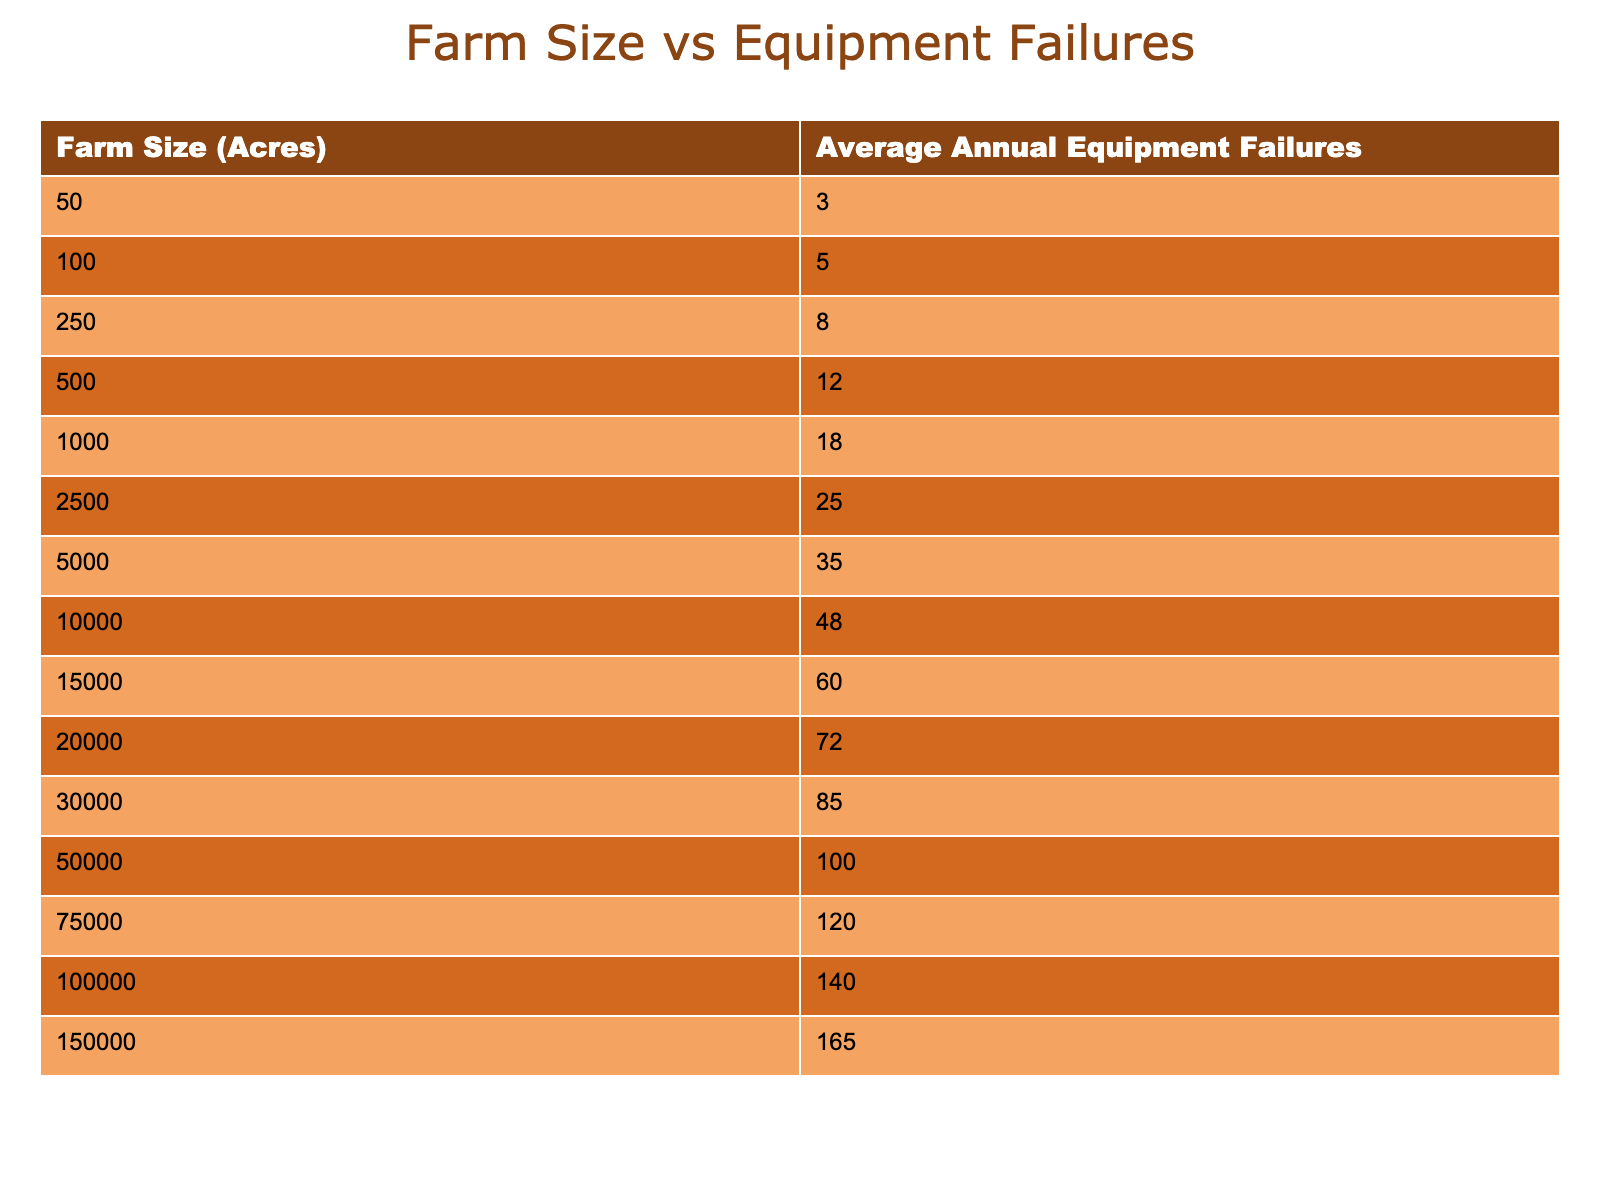What is the average number of equipment failures for farms larger than 10,000 acres? To find the average, we sum the number of failures for farms greater than 10,000 acres: 48 (10,000) + 60 (15,000) + 72 (20,000) + 85 (30,000) + 100 (50,000) + 120 (75,000) + 140 (100,000) + 165 (150,000) =  810. There are 8 entries, so the average is 810 / 8 = 101.25.
Answer: 101.25 How many total equipment failures occur for farms between 1,000 and 20,000 acres inclusive? The total for farms from 1,000 to 20,000 acres is the sum of failures at 1,000 (18) + 2,500 (25) + 5,000 (35) + 10,000 (48) + 15,000 (60) + 20,000 (72) = 258.
Answer: 258 Is there a farm size that sustains exactly 100 equipment failures? Upon examining the table, a farm size of 50,000 acres results in 100 equipment failures. Therefore, the answer is "yes."
Answer: Yes What is the difference in equipment failures between the smallest and largest farm sizes listed? From the table, the smallest farm size (50 acres) has 3 failures, and the largest (150,000 acres) has 165. The difference is 165 - 3 = 162.
Answer: 162 For the farm sizes presented, which size has the highest equipment failure rate, and what is that rate? The highest number of failures is 165 for the farm size of 150,000 acres. Therefore, this is the size with the highest failure rate.
Answer: 150,000 acres, 165 failures What is the trend of equipment failures as farm size increases? Observing the table, the trend clearly shows an increase in equipment failures as farm size increases. Each incremental increase in farm size results in higher failures indicating a positive correlation.
Answer: Positive correlation Calculate the median number of equipment failures across all listed farm sizes. To find the median, we need to list all equipment failures: 3, 5, 8, 12, 18, 25, 35, 48, 60, 72, 85, 100, 120, 140, 165. With 15 total data points, the median is the 8th value, which is 48.
Answer: 48 What is the farm size where equipment failures exceed 70? From the data, equipment failures exceed 70 starting at a farm size of 20,000 acres, as it goes from 72 (20,000) and continues to increase.
Answer: 20,000 acres How many more equipment failures does a 75,000-acre farm experience compared to a 50-acre farm? The 75,000-acre farm has 120 failures while the 50-acre farm has 3. Thus, the difference is 120 - 3 = 117 failures.
Answer: 117 Is there a consistent pattern of increase in equipment failures based on the farm size categories? Yes, from the table, equipment failures increase consistently as farm size categories increase, indicating a repeating pattern.
Answer: Yes 